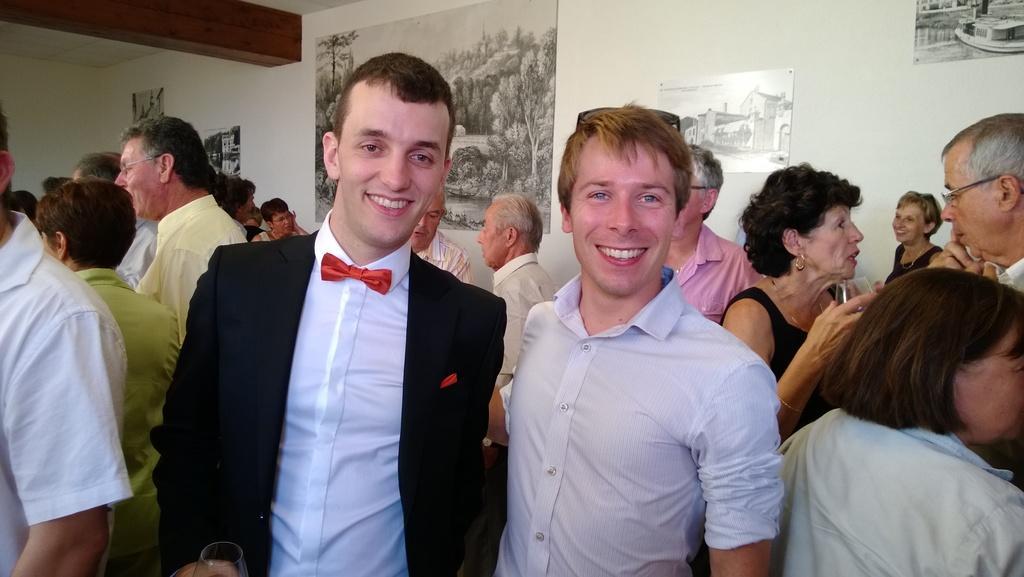Describe this image in one or two sentences. This image consists of many people in a room. In the front, there is a man wearing black suit and white shirt. Beside him, there is a man wearing white shirt. In the background, there is a wall on which frames are fixed. 